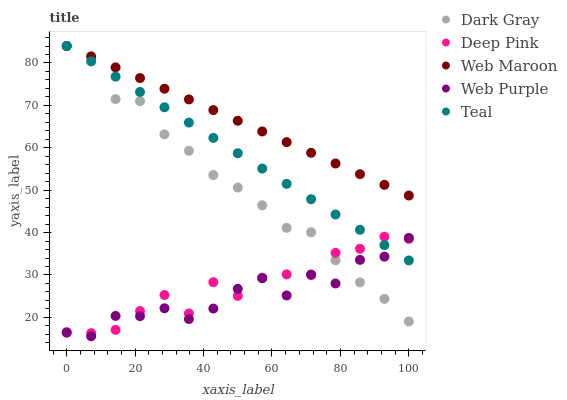Does Web Purple have the minimum area under the curve?
Answer yes or no. Yes. Does Web Maroon have the maximum area under the curve?
Answer yes or no. Yes. Does Deep Pink have the minimum area under the curve?
Answer yes or no. No. Does Deep Pink have the maximum area under the curve?
Answer yes or no. No. Is Web Maroon the smoothest?
Answer yes or no. Yes. Is Web Purple the roughest?
Answer yes or no. Yes. Is Deep Pink the smoothest?
Answer yes or no. No. Is Deep Pink the roughest?
Answer yes or no. No. Does Web Purple have the lowest value?
Answer yes or no. Yes. Does Deep Pink have the lowest value?
Answer yes or no. No. Does Teal have the highest value?
Answer yes or no. Yes. Does Deep Pink have the highest value?
Answer yes or no. No. Is Web Purple less than Web Maroon?
Answer yes or no. Yes. Is Web Maroon greater than Deep Pink?
Answer yes or no. Yes. Does Teal intersect Dark Gray?
Answer yes or no. Yes. Is Teal less than Dark Gray?
Answer yes or no. No. Is Teal greater than Dark Gray?
Answer yes or no. No. Does Web Purple intersect Web Maroon?
Answer yes or no. No. 